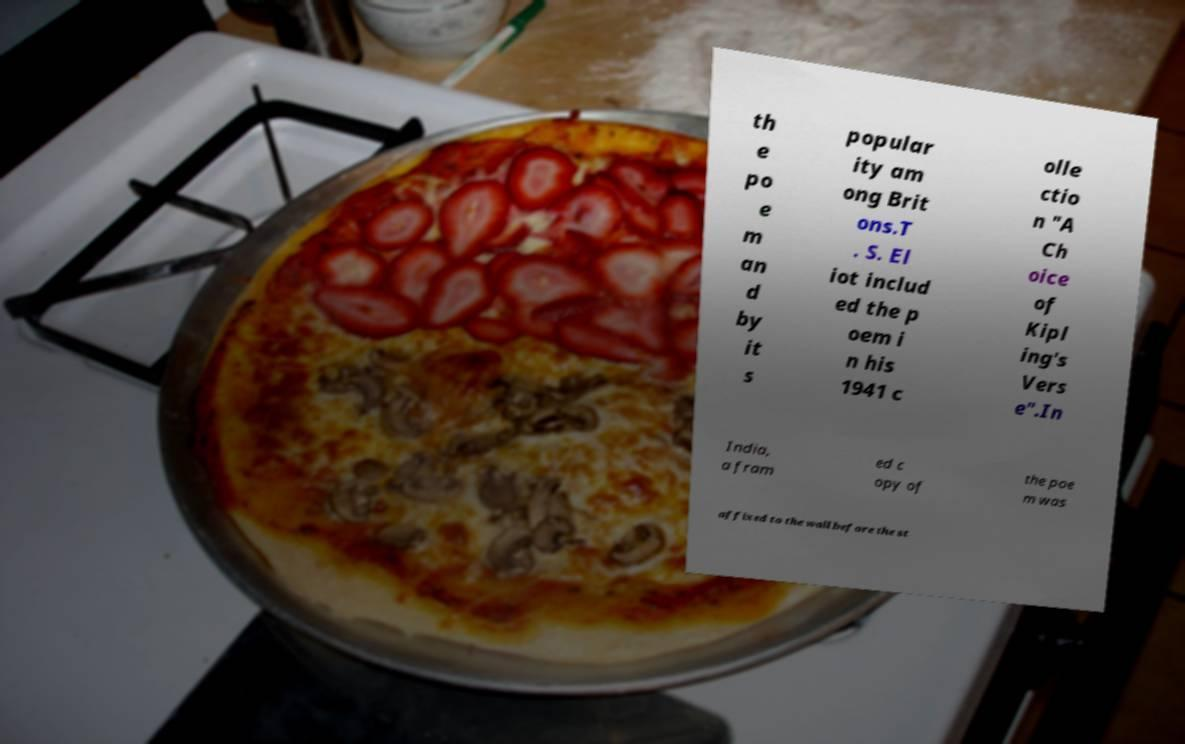What messages or text are displayed in this image? I need them in a readable, typed format. th e po e m an d by it s popular ity am ong Brit ons.T . S. El iot includ ed the p oem i n his 1941 c olle ctio n "A Ch oice of Kipl ing's Vers e".In India, a fram ed c opy of the poe m was affixed to the wall before the st 